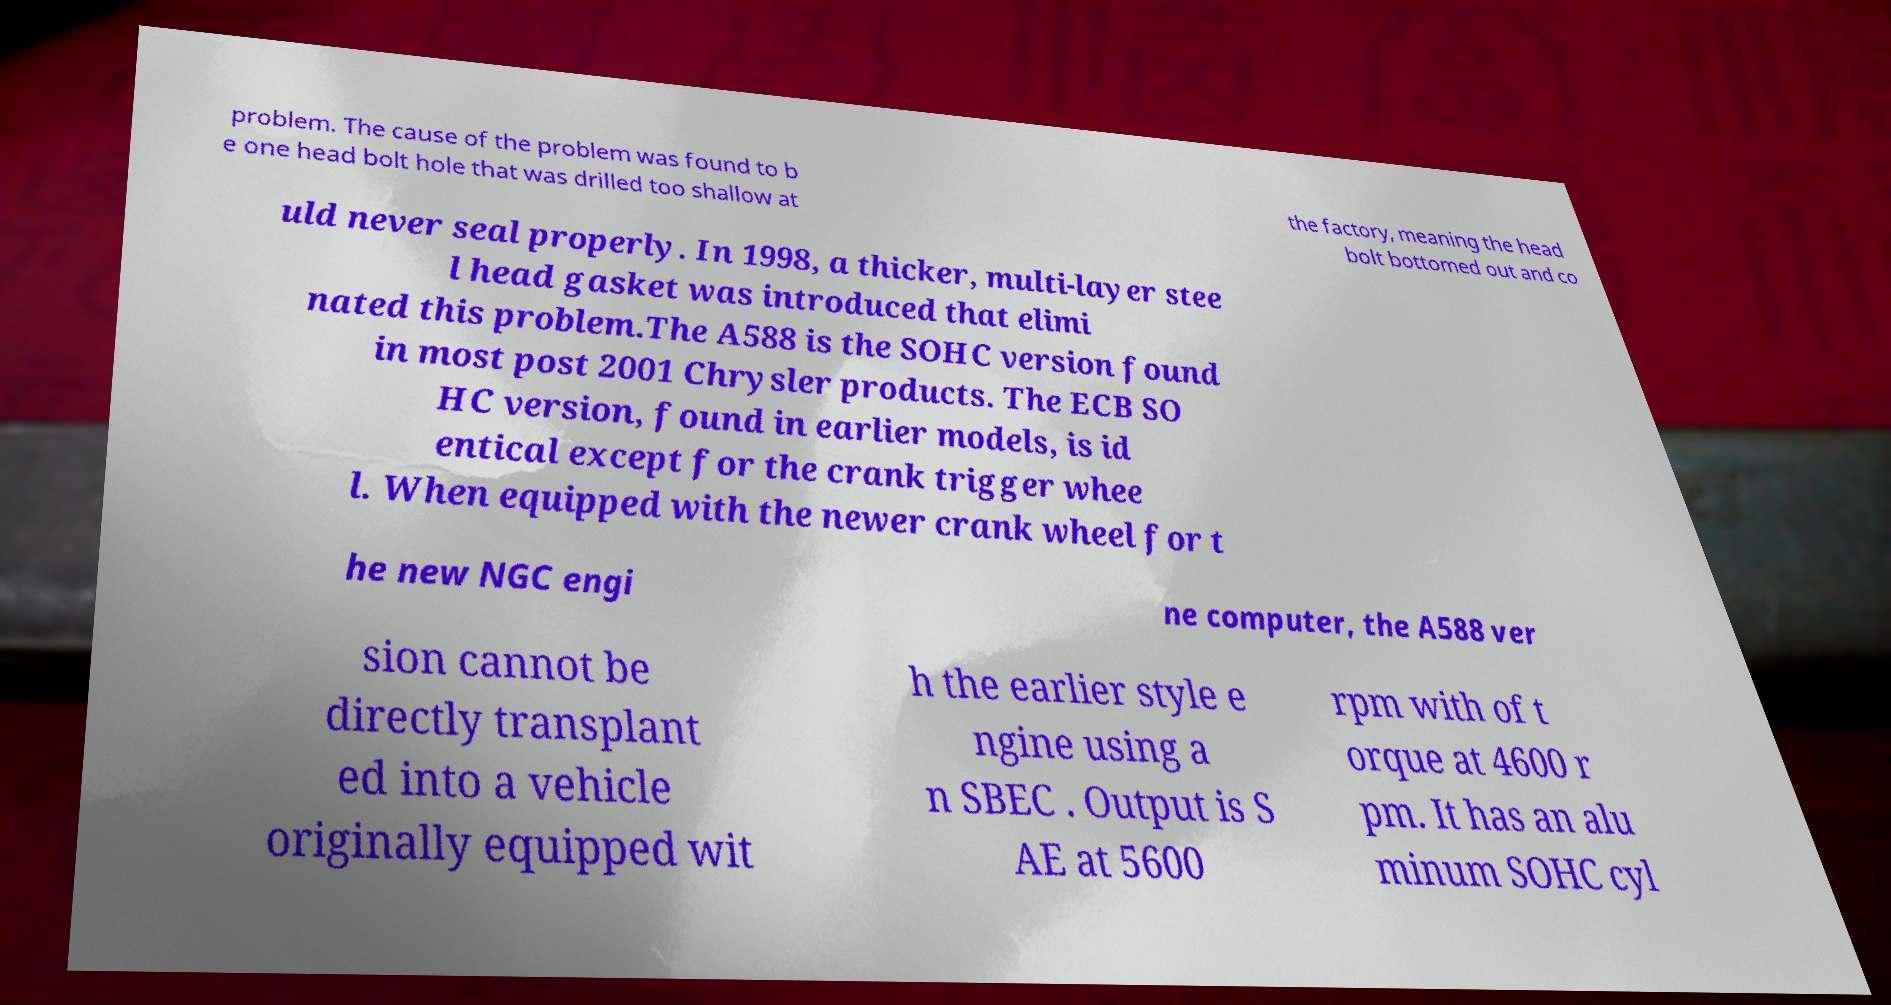What messages or text are displayed in this image? I need them in a readable, typed format. problem. The cause of the problem was found to b e one head bolt hole that was drilled too shallow at the factory, meaning the head bolt bottomed out and co uld never seal properly. In 1998, a thicker, multi-layer stee l head gasket was introduced that elimi nated this problem.The A588 is the SOHC version found in most post 2001 Chrysler products. The ECB SO HC version, found in earlier models, is id entical except for the crank trigger whee l. When equipped with the newer crank wheel for t he new NGC engi ne computer, the A588 ver sion cannot be directly transplant ed into a vehicle originally equipped wit h the earlier style e ngine using a n SBEC . Output is S AE at 5600 rpm with of t orque at 4600 r pm. It has an alu minum SOHC cyl 